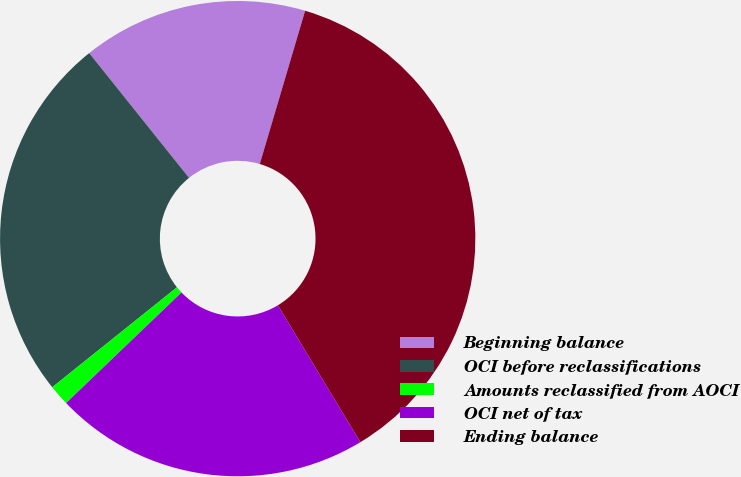Convert chart to OTSL. <chart><loc_0><loc_0><loc_500><loc_500><pie_chart><fcel>Beginning balance<fcel>OCI before reclassifications<fcel>Amounts reclassified from AOCI<fcel>OCI net of tax<fcel>Ending balance<nl><fcel>15.32%<fcel>25.01%<fcel>1.41%<fcel>21.47%<fcel>36.79%<nl></chart> 